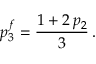Convert formula to latex. <formula><loc_0><loc_0><loc_500><loc_500>p _ { 3 } ^ { f } = \frac { 1 + 2 \, p _ { 2 } } { 3 } \, .</formula> 